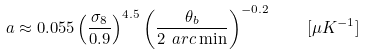Convert formula to latex. <formula><loc_0><loc_0><loc_500><loc_500>a \approx 0 . 0 5 5 \left ( \frac { \sigma _ { 8 } } { 0 . 9 } \right ) ^ { 4 . 5 } \left ( \frac { \theta _ { b } } { 2 \ a r c \min } \right ) ^ { - 0 . 2 } \quad [ \mu K ^ { - 1 } ]</formula> 